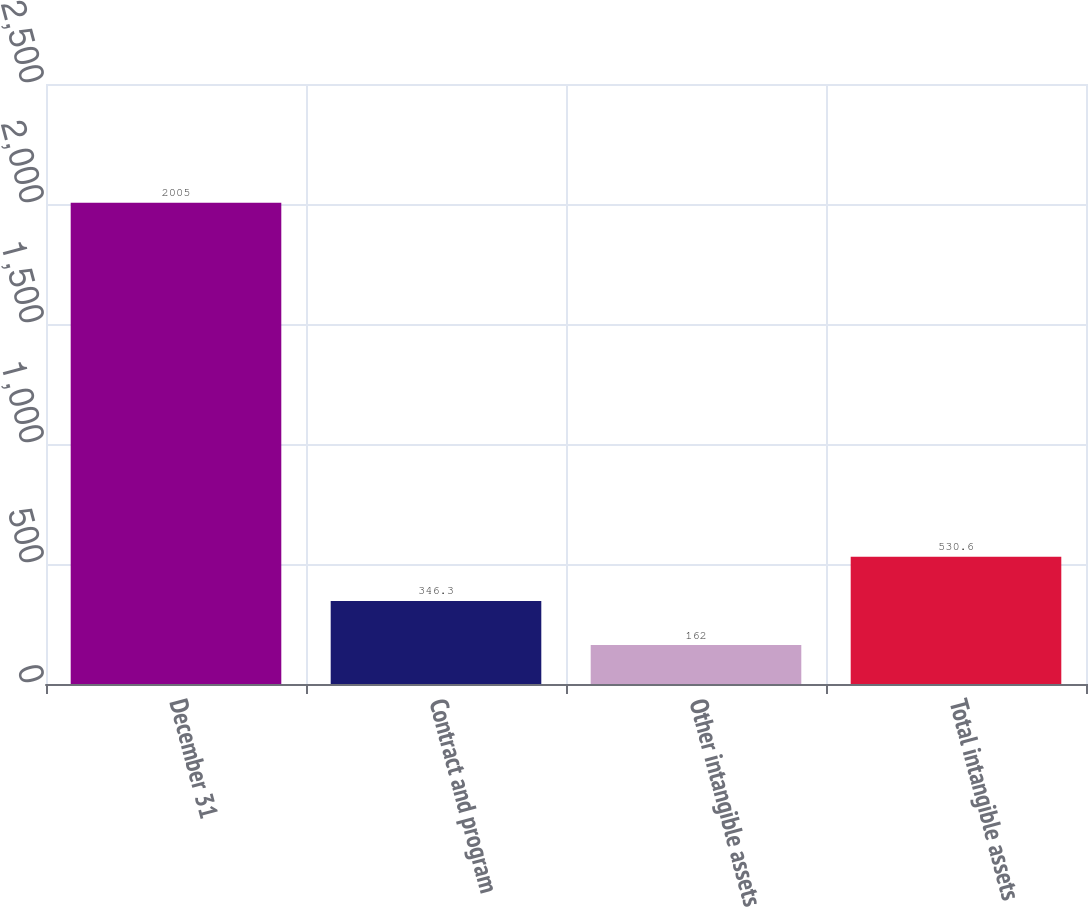Convert chart to OTSL. <chart><loc_0><loc_0><loc_500><loc_500><bar_chart><fcel>December 31<fcel>Contract and program<fcel>Other intangible assets<fcel>Total intangible assets<nl><fcel>2005<fcel>346.3<fcel>162<fcel>530.6<nl></chart> 